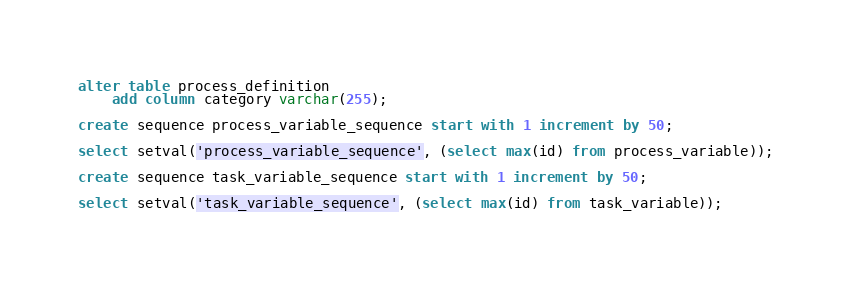<code> <loc_0><loc_0><loc_500><loc_500><_SQL_>alter table process_definition
    add column category varchar(255);

create sequence process_variable_sequence start with 1 increment by 50;

select setval('process_variable_sequence', (select max(id) from process_variable));

create sequence task_variable_sequence start with 1 increment by 50;

select setval('task_variable_sequence', (select max(id) from task_variable));
</code> 